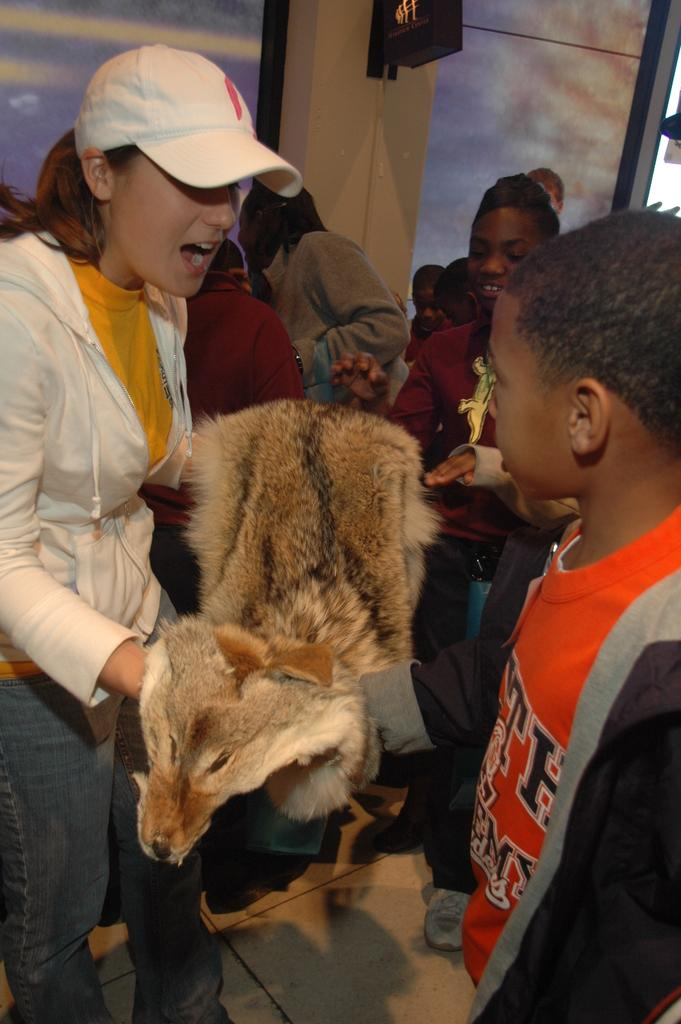What is the main subject of the image? The main subject of the image is a beautiful girl. Where is the girl positioned in the image? The girl is standing on the left side of the image. What is the girl doing in the image? The girl is speaking. What is the girl wearing in the image? The girl is wearing a white color sweater and a cap. Can you describe the boy in the image? Yes, there is a boy in the image, and he is on the right side. He is looking at the girl and wearing an orange color t-shirt. What type of quiver can be seen in the image? There is no quiver present in the image. How does the girl's behavior change from minute to minute in the image? The image is a still photograph, so the girl's behavior does not change from minute to minute. 